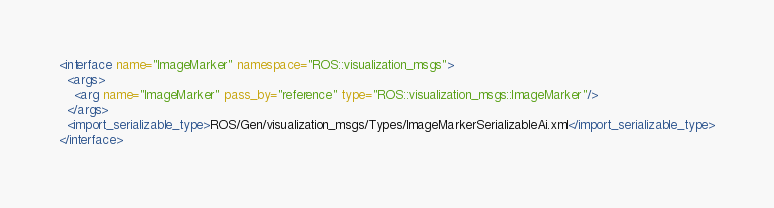Convert code to text. <code><loc_0><loc_0><loc_500><loc_500><_XML_><interface name="ImageMarker" namespace="ROS::visualization_msgs">
  <args>
    <arg name="ImageMarker" pass_by="reference" type="ROS::visualization_msgs::ImageMarker"/>
  </args>
  <import_serializable_type>ROS/Gen/visualization_msgs/Types/ImageMarkerSerializableAi.xml</import_serializable_type>
</interface>
</code> 